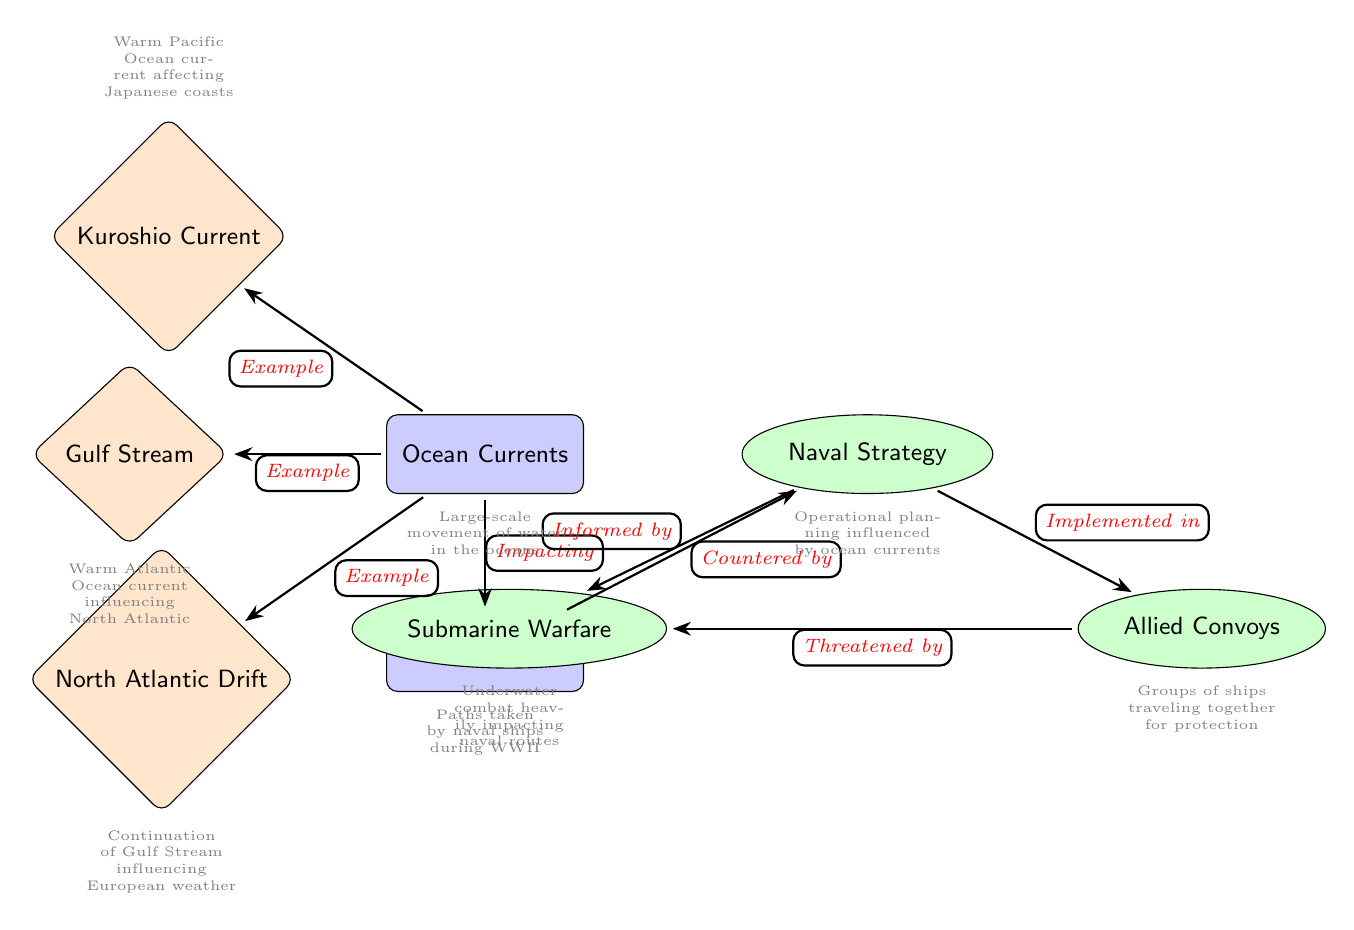What is at the top node of the diagram? The top node in the diagram is labeled "Ocean Currents," which represents large-scale movements of water in the oceans.
Answer: Ocean Currents How many example nodes are displayed in the diagram? The diagram shows three example nodes, which are the Gulf Stream, Kuroshio Current, and North Atlantic Drift.
Answer: 3 What is the relationship between Ocean Currents and Naval Routes? The diagram describes the relationship with the edge labeled "Impacting," indicating that ocean currents have an influence on the paths taken by naval ships.
Answer: Impacting Which current is mentioned as threatening Allied convoys? The diagram specifies that submarine warfare is threatening Allied convoys, indicating that it is a major consideration in naval strategy during WWII.
Answer: Submarine Warfare Which node is influenced by both Naval Strategy and Ocean Currents? The node "Naval Routes" is influenced by both "Naval Strategy" through the connection labeled "Informed by" and by "Ocean Currents" via "Impacting."
Answer: Naval Routes Explain how Allied Convoys are related to Submarine Warfare according to the diagram. The diagram shows that Allied Convoys are threatened by Submarine Warfare, establishing a direct relationship where the latter poses a risk to the former during WWII naval operations.
Answer: Threatened by What does the Gulf Stream affect according to the diagram? The Gulf Stream impacts the North Atlantic Ocean, as mentioned in the description next to the example node in the diagram.
Answer: North Atlantic What does the Naval Strategy node inform according to the diagram? The "Naval Strategy" node informs the "Naval Routes" node, indicating that strategies developed during WWII were directly related to the chosen paths for naval ships.
Answer: Naval Routes Which ocean current is labeled as having a direct influence on European weather? The diagram suggests that the North Atlantic Drift, as a continuation of the Gulf Stream, directly influences European weather patterns.
Answer: North Atlantic Drift 